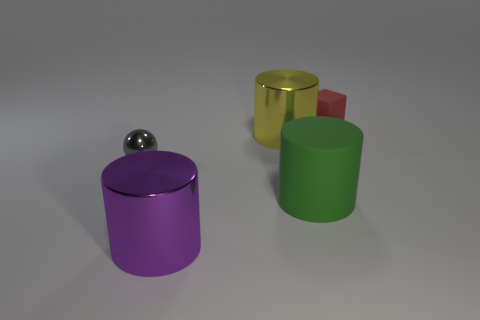How many small gray objects are to the right of the big purple shiny cylinder?
Provide a short and direct response. 0. Does the cylinder that is behind the gray object have the same color as the ball?
Ensure brevity in your answer.  No. What number of other purple cylinders have the same size as the matte cylinder?
Offer a terse response. 1. What shape is the yellow object that is made of the same material as the gray object?
Offer a very short reply. Cylinder. Is there a shiny cylinder of the same color as the large rubber object?
Provide a short and direct response. No. What material is the ball?
Provide a succinct answer. Metal. What number of things are green shiny things or metallic spheres?
Offer a terse response. 1. There is a rubber thing that is left of the red block; what size is it?
Provide a succinct answer. Large. How many other objects are there of the same material as the red block?
Offer a very short reply. 1. Are there any tiny things in front of the purple thing in front of the tiny gray ball?
Your answer should be very brief. No. 